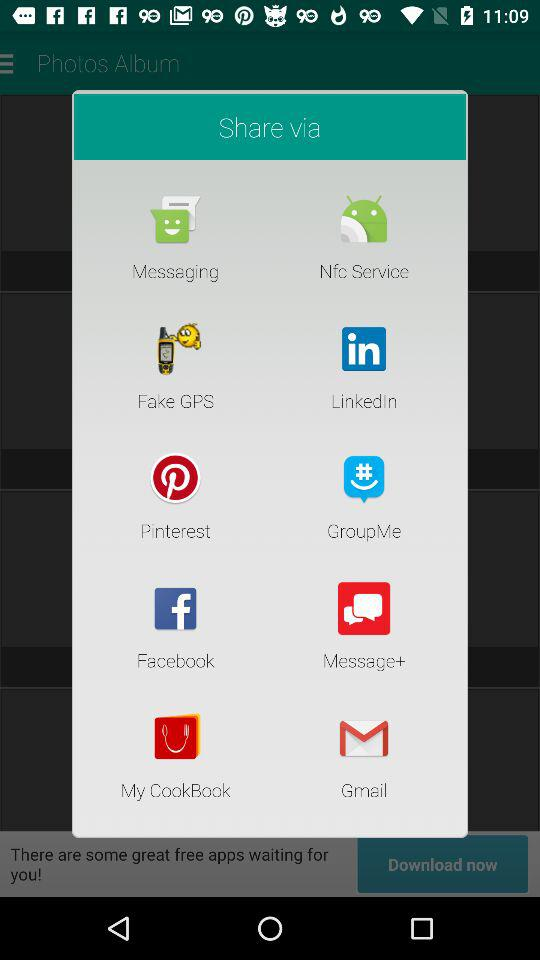Which item is not an app?
Answer the question using a single word or phrase. Nfc Service 